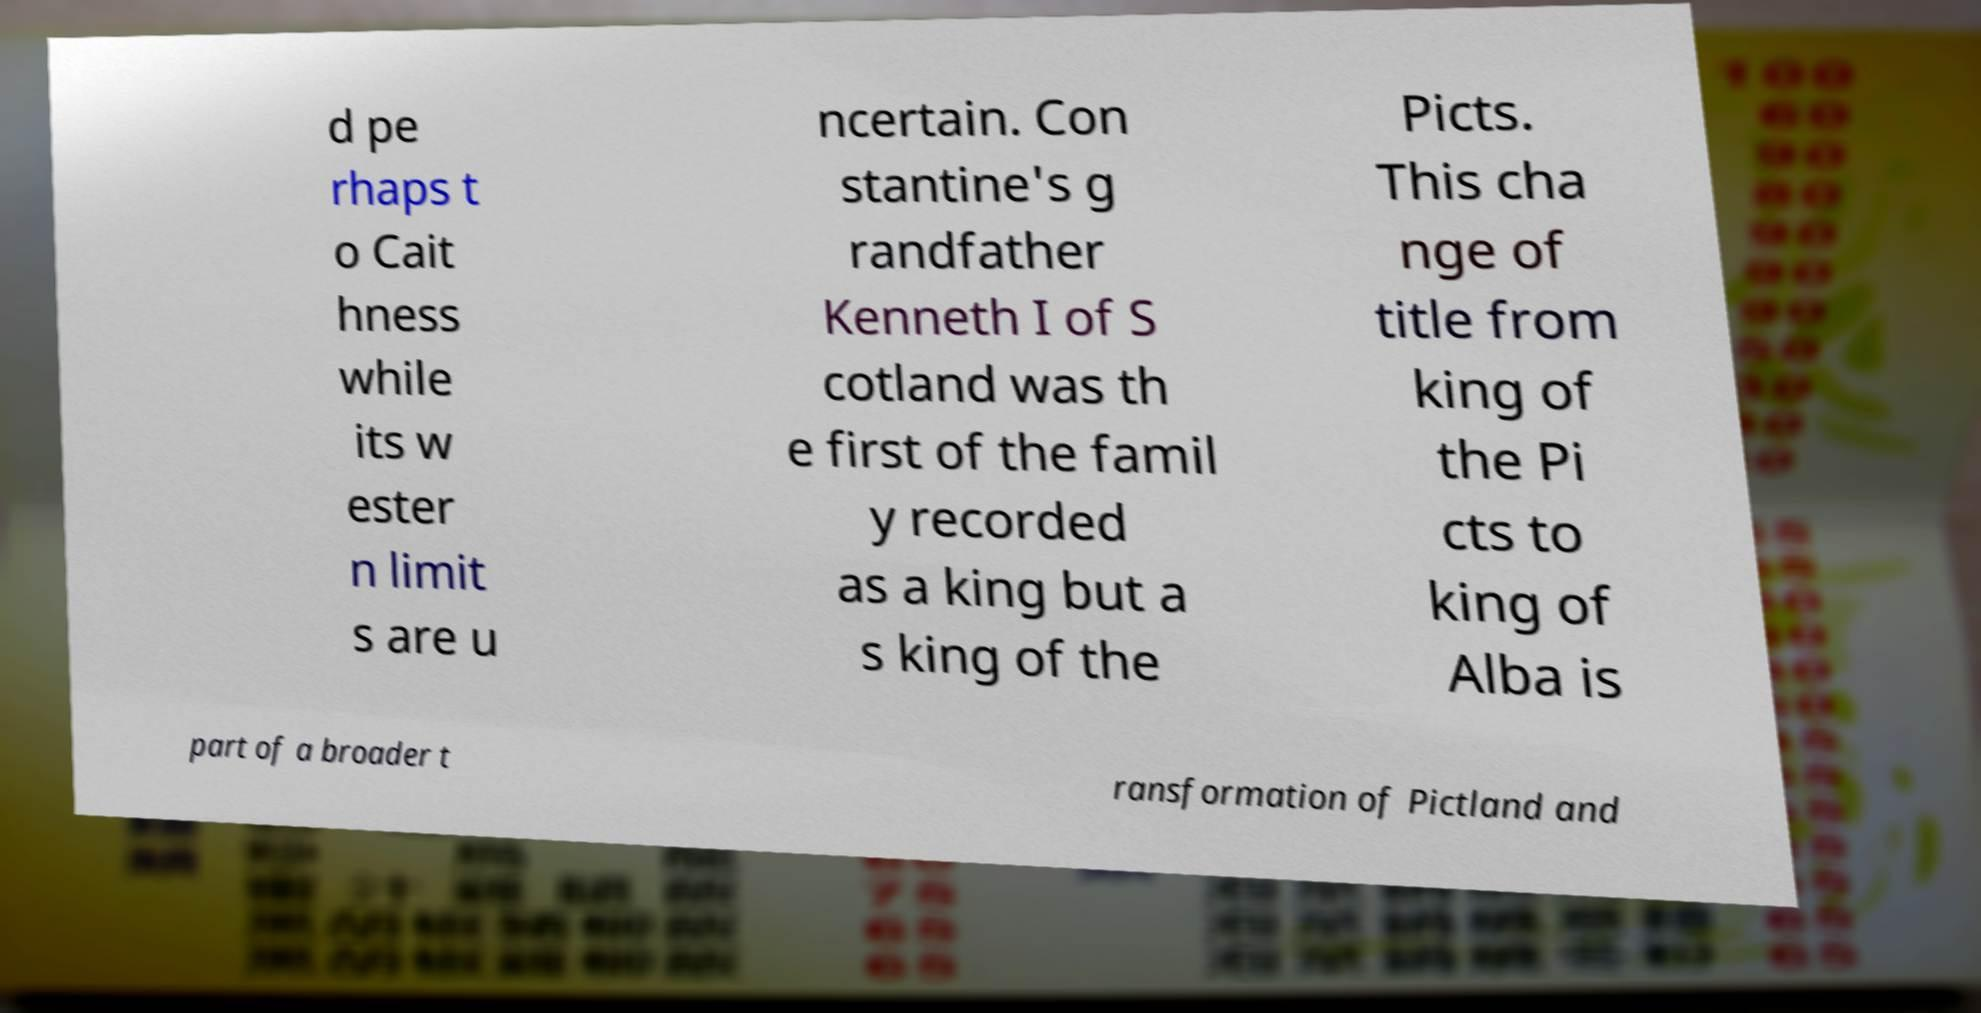What messages or text are displayed in this image? I need them in a readable, typed format. d pe rhaps t o Cait hness while its w ester n limit s are u ncertain. Con stantine's g randfather Kenneth I of S cotland was th e first of the famil y recorded as a king but a s king of the Picts. This cha nge of title from king of the Pi cts to king of Alba is part of a broader t ransformation of Pictland and 